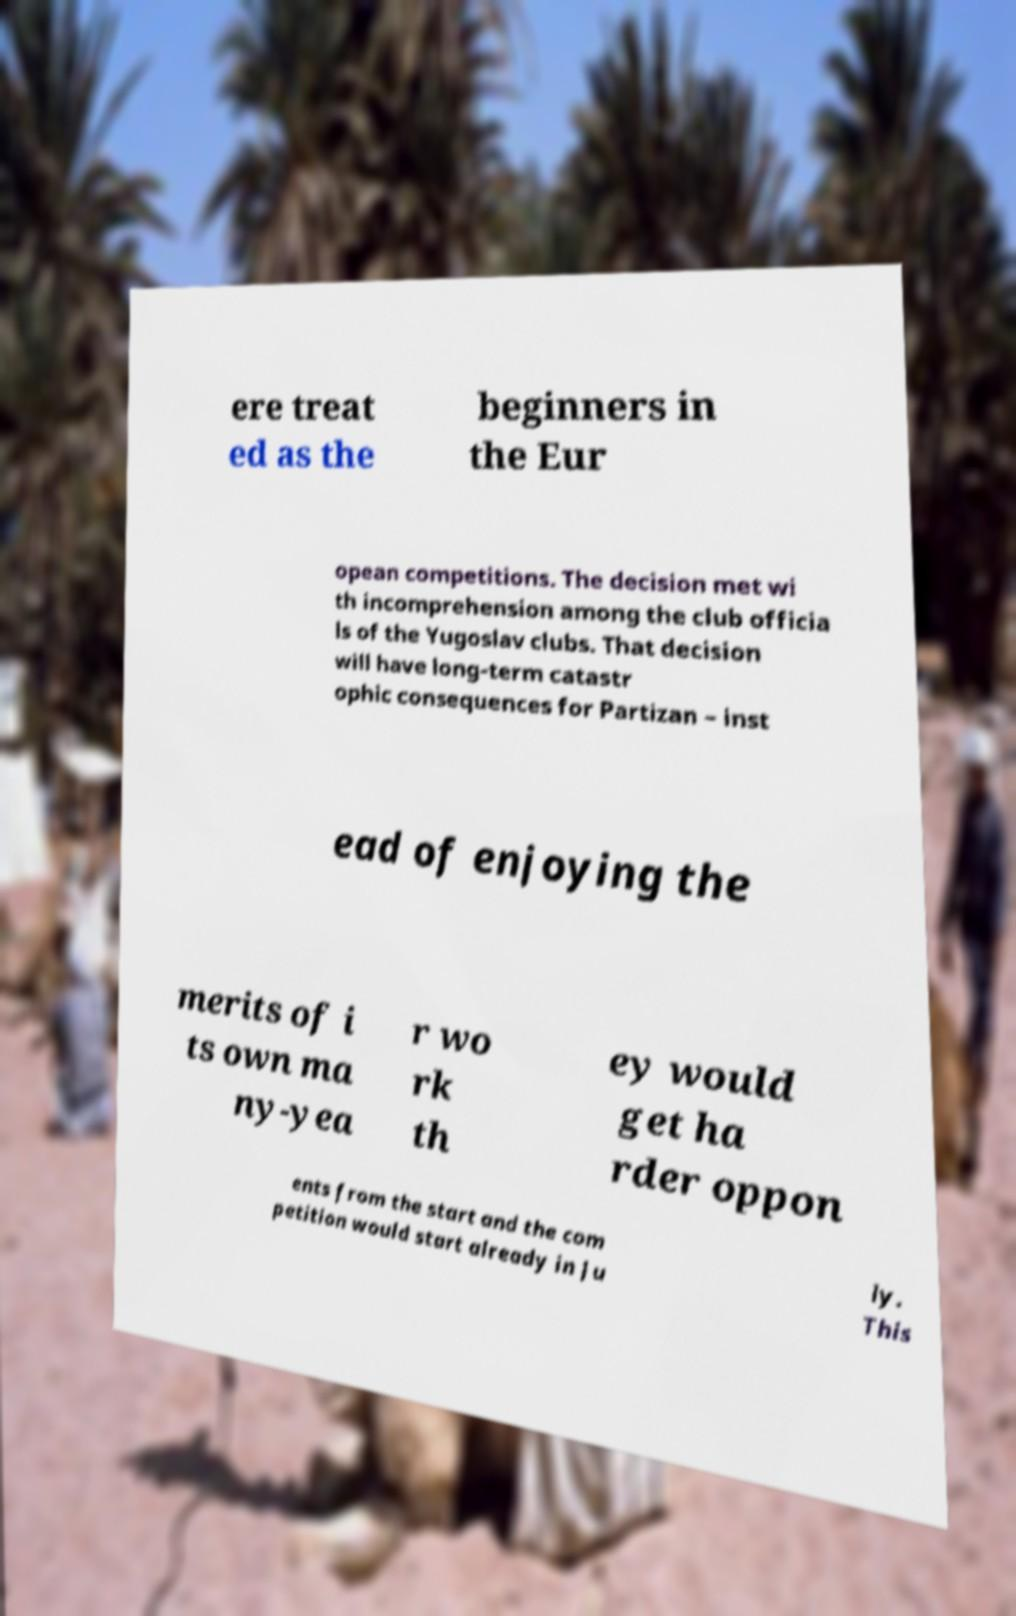I need the written content from this picture converted into text. Can you do that? ere treat ed as the beginners in the Eur opean competitions. The decision met wi th incomprehension among the club officia ls of the Yugoslav clubs. That decision will have long-term catastr ophic consequences for Partizan – inst ead of enjoying the merits of i ts own ma ny-yea r wo rk th ey would get ha rder oppon ents from the start and the com petition would start already in Ju ly. This 